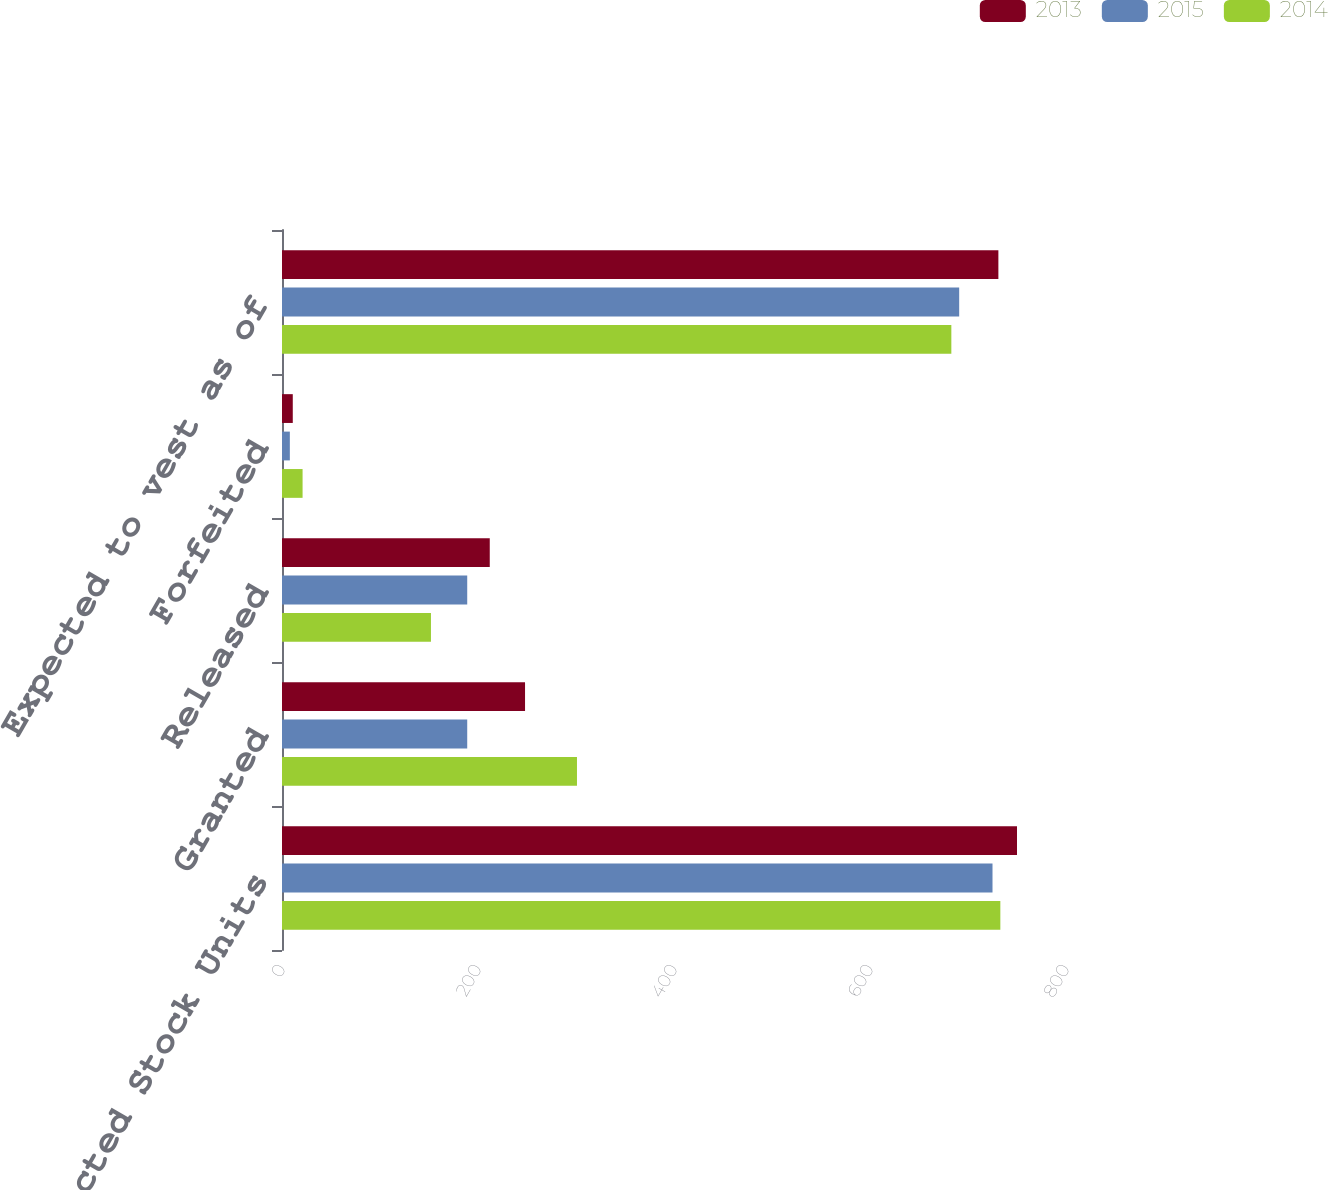<chart> <loc_0><loc_0><loc_500><loc_500><stacked_bar_chart><ecel><fcel>Restricted Stock Units<fcel>Granted<fcel>Released<fcel>Forfeited<fcel>Expected to vest as of<nl><fcel>2013<fcel>750<fcel>248<fcel>212<fcel>11<fcel>731<nl><fcel>2015<fcel>725<fcel>189<fcel>189<fcel>8<fcel>691<nl><fcel>2014<fcel>733<fcel>301<fcel>152<fcel>21<fcel>683<nl></chart> 